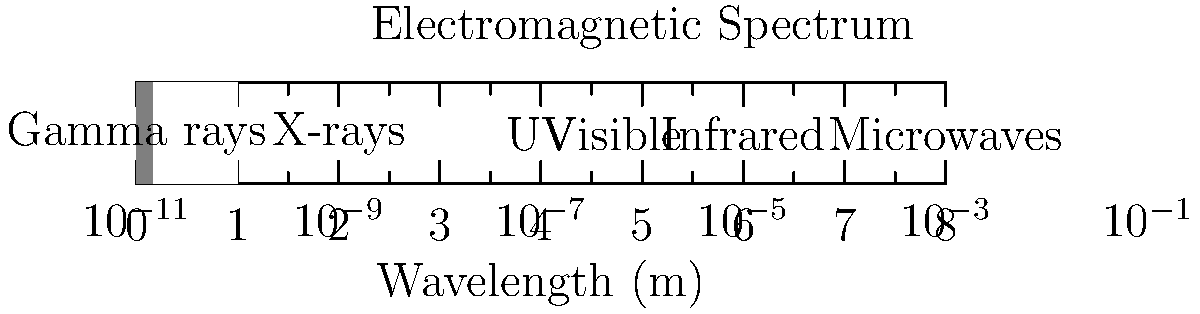Based on the electromagnetic spectrum chart shown, which type of radiation is most commonly used in chest X-rays, and what is its approximate wavelength range? To answer this question, let's follow these steps:

1. Examine the electromagnetic spectrum chart:
   The chart shows different types of electromagnetic radiation arranged by wavelength.

2. Identify the radiation used in chest X-rays:
   X-rays are commonly used for chest imaging in medical diagnostics.

3. Locate X-rays on the spectrum:
   X-rays are shown in the second band from the left on the chart.

4. Determine the wavelength range for X-rays:
   The X-ray band is between $10^{-11}$ m and $10^{-9}$ m on the wavelength scale.

5. Approximate the wavelength range:
   The typical wavelength range for X-rays used in medical imaging is approximately $10^{-10}$ m to $10^{-9}$ m.

Therefore, X-rays with a wavelength range of approximately $10^{-10}$ m to $10^{-9}$ m are most commonly used for chest X-rays.
Answer: X-rays, $10^{-10}$ m to $10^{-9}$ m 